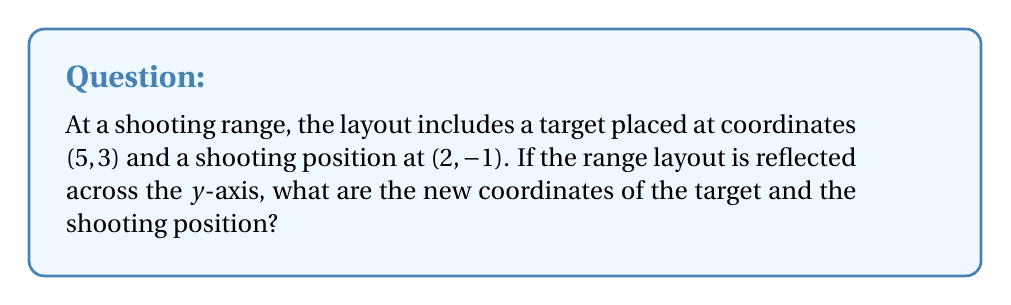Can you answer this question? To reflect a point across the y-axis, we keep the y-coordinate the same and negate the x-coordinate. This is because the y-axis acts as a mirror, flipping the image horizontally.

For the target at (5, 3):
1. The x-coordinate changes from 5 to -5
2. The y-coordinate remains 3
New target position: (-5, 3)

For the shooting position at (2, -1):
1. The x-coordinate changes from 2 to -2
2. The y-coordinate remains -1
New shooting position: (-2, -1)

We can express this transformation mathematically as:
$$(x, y) \rightarrow (-x, y)$$

This reflection can be represented by the following matrix multiplication:
$$\begin{bmatrix} -1 & 0 \\ 0 & 1 \end{bmatrix} \begin{bmatrix} x \\ y \end{bmatrix} = \begin{bmatrix} -x \\ y \end{bmatrix}$$

[asy]
unitsize(1cm);
draw((-6,0)--(6,0),arrow=Arrow(TeXHead));
draw((0,-2)--(0,4),arrow=Arrow(TeXHead));
dot((5,3),red);
dot((-5,3),blue);
dot((2,-1),red);
dot((-2,-1),blue);
label("Original target",(5,3),E,red);
label("Reflected target",(-5,3),W,blue);
label("Original position",(2,-1),E,red);
label("Reflected position",(-2,-1),W,blue);
label("x",(-6,0),SW);
label("y",(0,4),NW);
[/asy]
Answer: The reflected coordinates are: Target at (-5, 3) and shooting position at (-2, -1). 